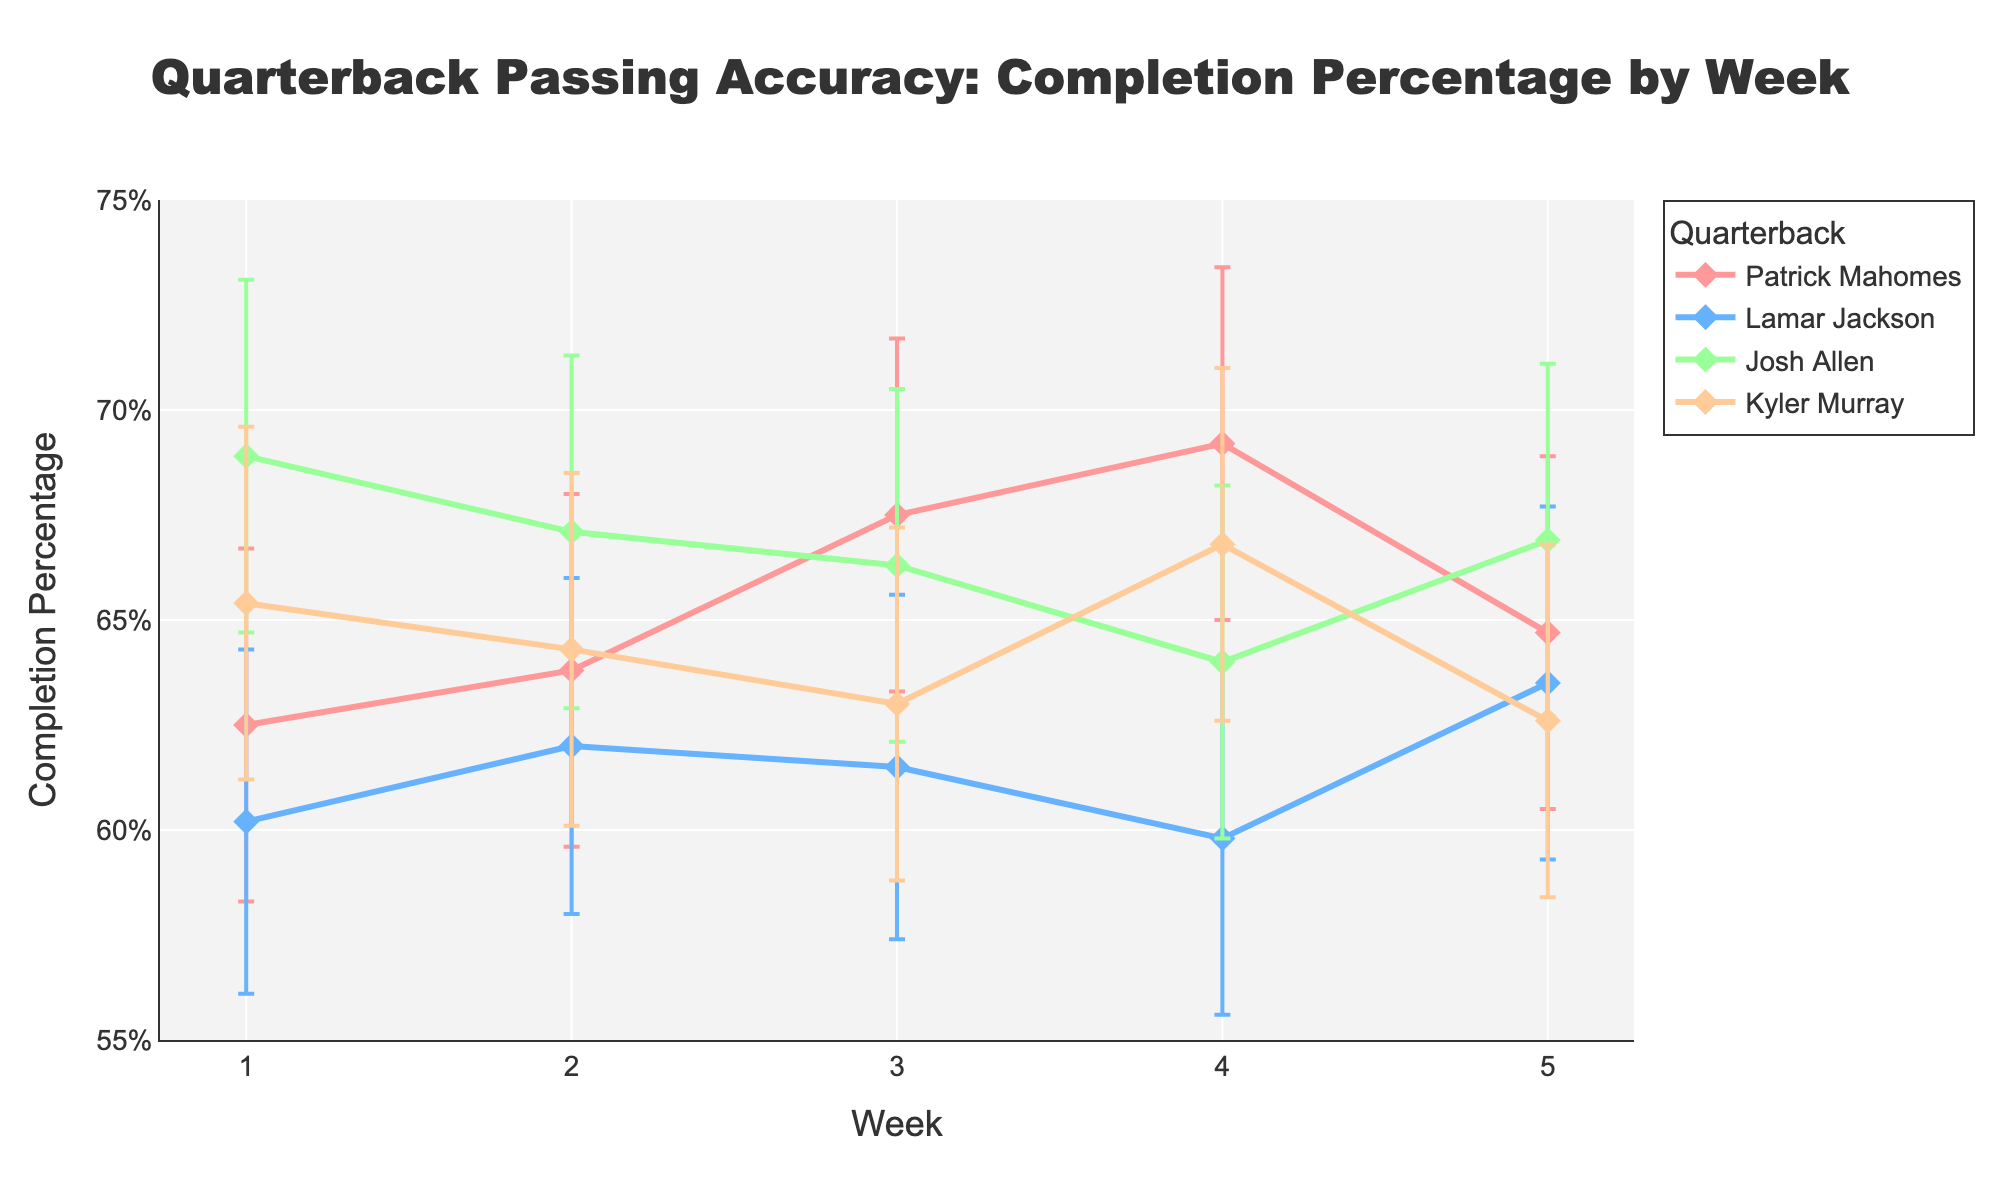What is the title of the plot? To find the title of the plot, look at the top center of the figure where the plot title is typically displayed.
Answer: Quarterback Passing Accuracy: Completion Percentage by Week Which quarterback has the highest completion percentage in Week 1? To answer this, locate Week 1 on the x-axis and compare the completion percentages of all quarterbacks for that week.
Answer: Josh Allen How many weeks does Kyler Murray have a completion percentage above 65%? Trace Kyler Murray's line across the weeks and count the instances where the y-values (completion percentages) are above 65%.
Answer: 2 weeks In Week 3, whose completion percentage is closest to the lower confidence interval of Josh Allen? Identify Josh Allen's lower confidence interval in Week 3, then compare the completion percentages of the other quarterbacks to find the closest one.
Answer: Kyler Murray By how much does Patrick Mahomes' completion percentage increase from Week 1 to Week 4? Subtract Patrick Mahomes' completion percentage in Week 1 from his completion percentage in Week 4.
Answer: 6.7% Which quarterback shows the most consistent completion percentage over the 5 weeks? The most consistent completion percentage can be inferred from the line with the least fluctuations and smallest error bars over the 5 weeks.
Answer: Kyler Murray What is the average completion percentage of Lamar Jackson across all weeks? Sum all the completion percentages of Lamar Jackson for each week and divide by the number of weeks.
Answer: 61.4% Which player's completion percentage has the widest confidence interval range in Week 5? Calculate the difference between the upper and lower confidence intervals for each player in Week 5 and identify the largest range.
Answer: Patrick Mahomes How does the completion percentage of Josh Allen compare to that of Patrick Mahomes in Week 2? Compare the y-values (completion percentages) of Josh Allen and Patrick Mahomes in Week 2 directly from the plot.
Answer: Josh Allen is higher Across all players, which week has the highest average completion percentage? Calculate the average completion percentage for each week by summing the completion percentages of all quarterbacks for that week and divide by the number of players. Identify the week with the highest value.
Answer: Week 4 